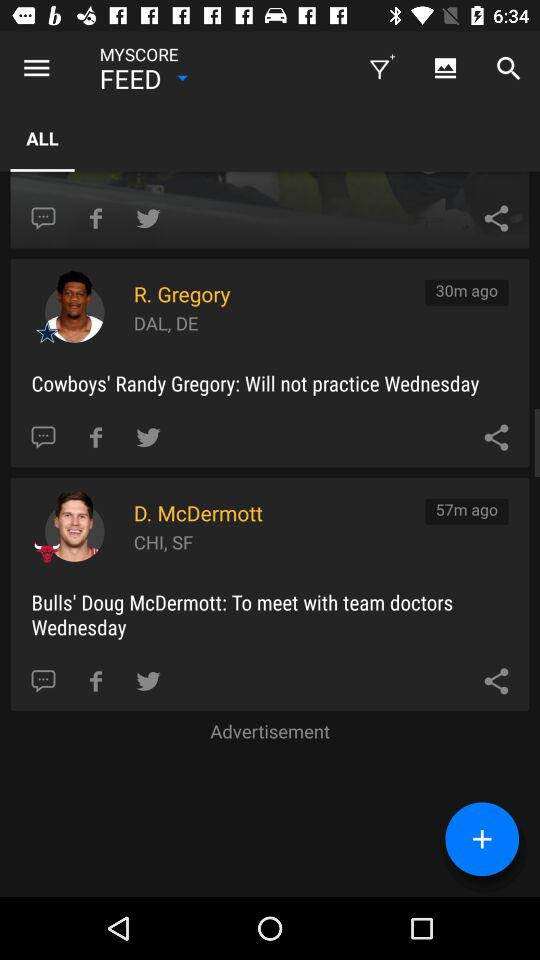How many more minutes ago was the update for D. McDermott than R. Gregory? The update for D. McDermott was posted 27 minutes earlier than the update for R. Gregory. Specifically, McDermott's update came 57 minutes ago, while Gregory's was 30 minutes ago. 